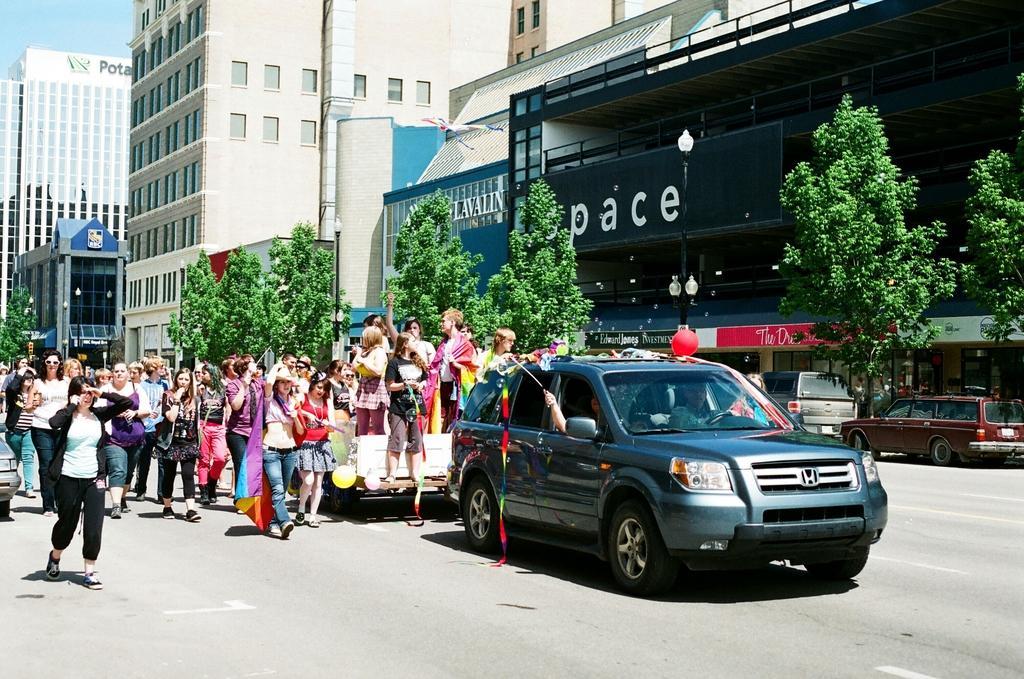In one or two sentences, can you explain what this image depicts? In the image there are many people standing and walking on the road with a car moving in front of them and in the back there are buildings with trees and vehicles in front of it. 